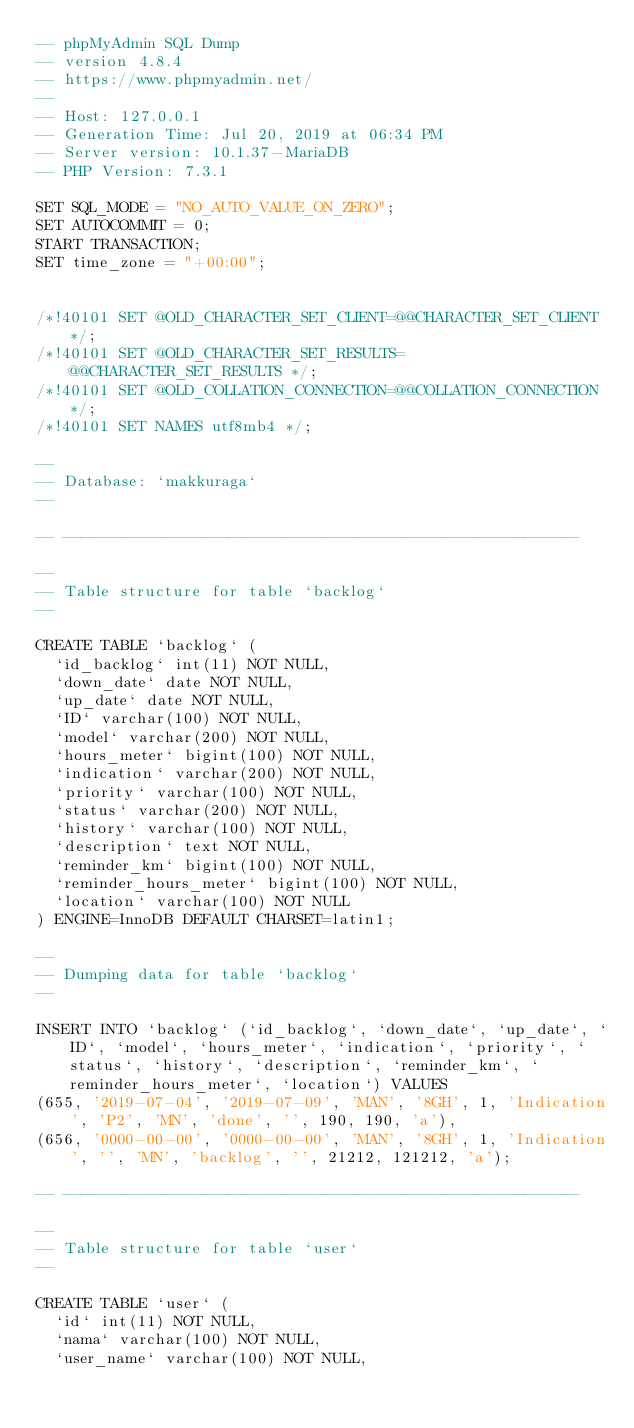Convert code to text. <code><loc_0><loc_0><loc_500><loc_500><_SQL_>-- phpMyAdmin SQL Dump
-- version 4.8.4
-- https://www.phpmyadmin.net/
--
-- Host: 127.0.0.1
-- Generation Time: Jul 20, 2019 at 06:34 PM
-- Server version: 10.1.37-MariaDB
-- PHP Version: 7.3.1

SET SQL_MODE = "NO_AUTO_VALUE_ON_ZERO";
SET AUTOCOMMIT = 0;
START TRANSACTION;
SET time_zone = "+00:00";


/*!40101 SET @OLD_CHARACTER_SET_CLIENT=@@CHARACTER_SET_CLIENT */;
/*!40101 SET @OLD_CHARACTER_SET_RESULTS=@@CHARACTER_SET_RESULTS */;
/*!40101 SET @OLD_COLLATION_CONNECTION=@@COLLATION_CONNECTION */;
/*!40101 SET NAMES utf8mb4 */;

--
-- Database: `makkuraga`
--

-- --------------------------------------------------------

--
-- Table structure for table `backlog`
--

CREATE TABLE `backlog` (
  `id_backlog` int(11) NOT NULL,
  `down_date` date NOT NULL,
  `up_date` date NOT NULL,
  `ID` varchar(100) NOT NULL,
  `model` varchar(200) NOT NULL,
  `hours_meter` bigint(100) NOT NULL,
  `indication` varchar(200) NOT NULL,
  `priority` varchar(100) NOT NULL,
  `status` varchar(200) NOT NULL,
  `history` varchar(100) NOT NULL,
  `description` text NOT NULL,
  `reminder_km` bigint(100) NOT NULL,
  `reminder_hours_meter` bigint(100) NOT NULL,
  `location` varchar(100) NOT NULL
) ENGINE=InnoDB DEFAULT CHARSET=latin1;

--
-- Dumping data for table `backlog`
--

INSERT INTO `backlog` (`id_backlog`, `down_date`, `up_date`, `ID`, `model`, `hours_meter`, `indication`, `priority`, `status`, `history`, `description`, `reminder_km`, `reminder_hours_meter`, `location`) VALUES
(655, '2019-07-04', '2019-07-09', 'MAN', '8GH', 1, 'Indication', 'P2', 'MN', 'done', '', 190, 190, 'a'),
(656, '0000-00-00', '0000-00-00', 'MAN', '8GH', 1, 'Indication', '', 'MN', 'backlog', '', 21212, 121212, 'a');

-- --------------------------------------------------------

--
-- Table structure for table `user`
--

CREATE TABLE `user` (
  `id` int(11) NOT NULL,
  `nama` varchar(100) NOT NULL,
  `user_name` varchar(100) NOT NULL,</code> 